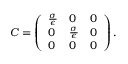Convert formula to latex. <formula><loc_0><loc_0><loc_500><loc_500>C = \left ( { \begin{array} { l l l } { { \frac { \sigma } { \epsilon } } } & { 0 } & { 0 } \\ { 0 } & { { \frac { \sigma } { \epsilon } } } & { 0 } \\ { 0 } & { 0 } & { 0 } \end{array} } \right ) .</formula> 